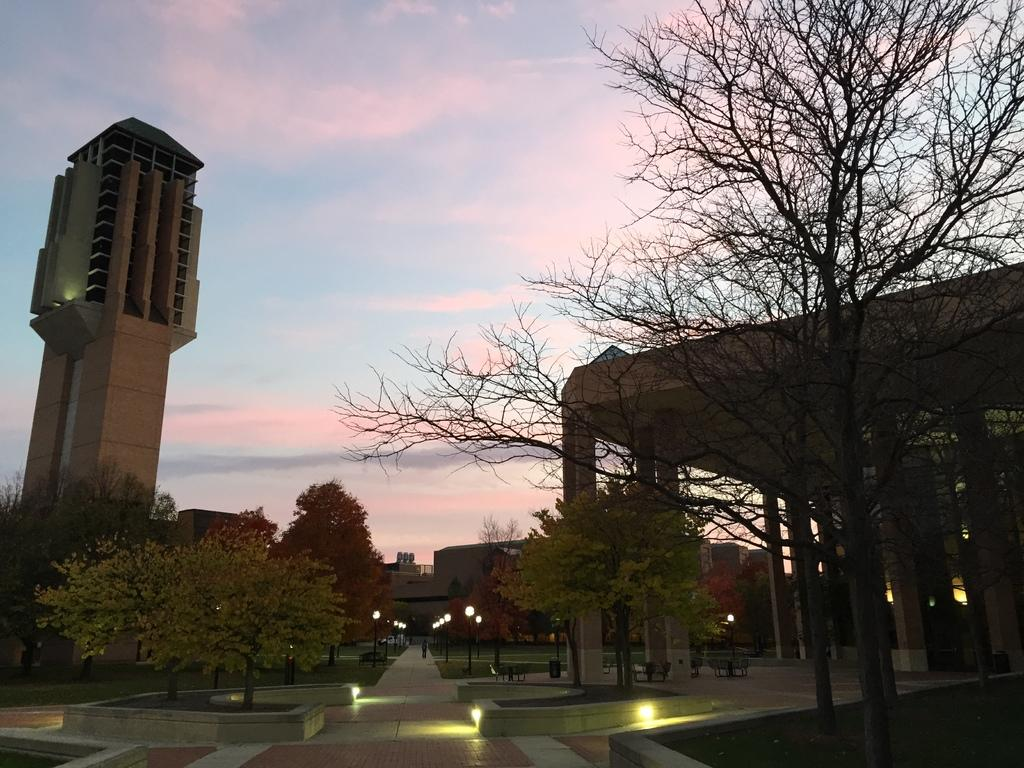What type of structures can be seen in the image? There are buildings in the image. What other natural elements are present in the image? There are trees in the image. What type of lighting is present in the image? There are pole lights in the image. How would you describe the sky in the image? The sky is blue and cloudy in the image. What type of breakfast is being served on the table in the image? There is no table or breakfast present in the image; it only features buildings, trees, pole lights, and a blue and cloudy sky. 